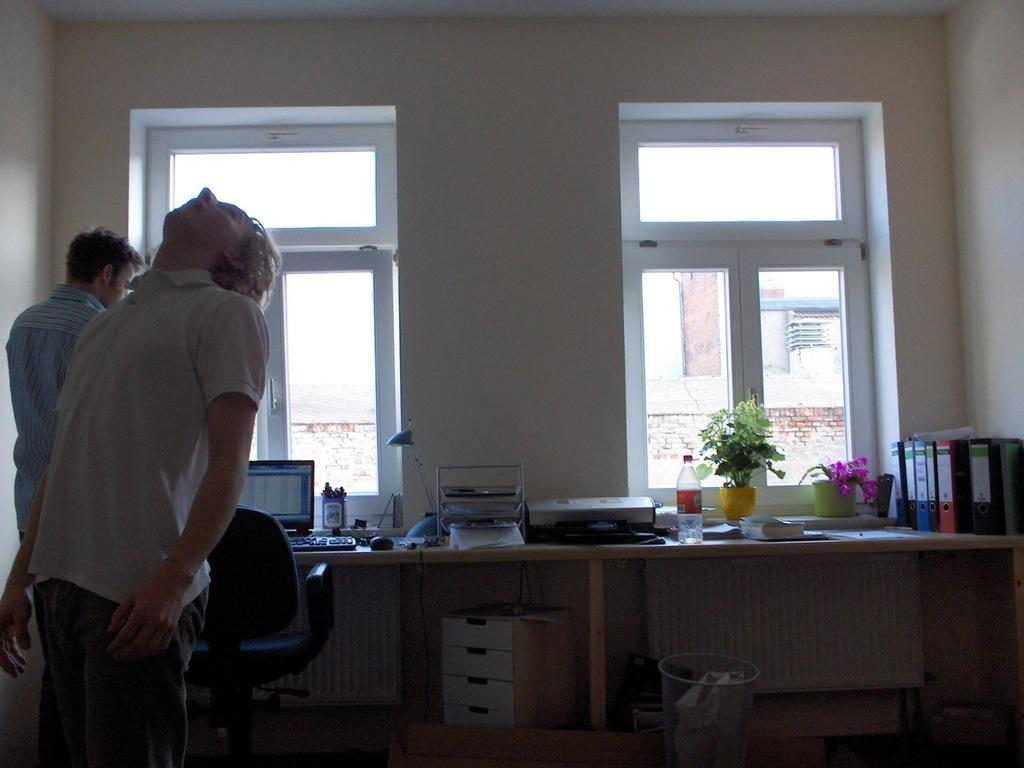How many people are in the room in the image? There are two people in the room. What type of furniture is present in the room? There are chairs and tables in the room. What can be found on the tables in the room? There are many things on the tables in the room. What type of paste is being used by the people in the room? There is no paste visible in the image, and no indication that the people are using any paste. 